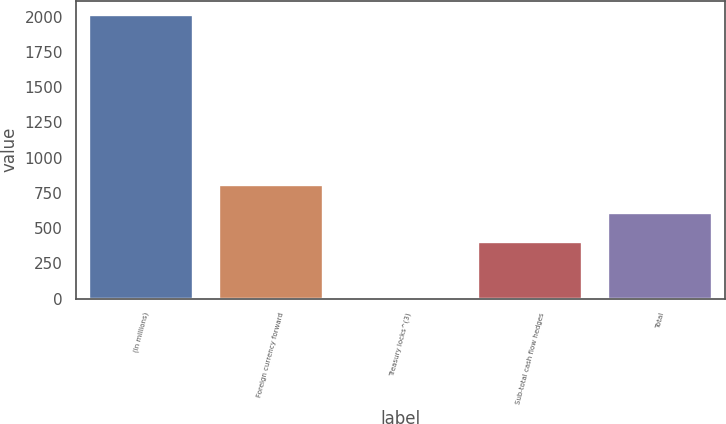Convert chart to OTSL. <chart><loc_0><loc_0><loc_500><loc_500><bar_chart><fcel>(In millions)<fcel>Foreign currency forward<fcel>Treasury locks^(3)<fcel>Sub-total cash flow hedges<fcel>Total<nl><fcel>2013<fcel>805.26<fcel>0.1<fcel>402.68<fcel>603.97<nl></chart> 